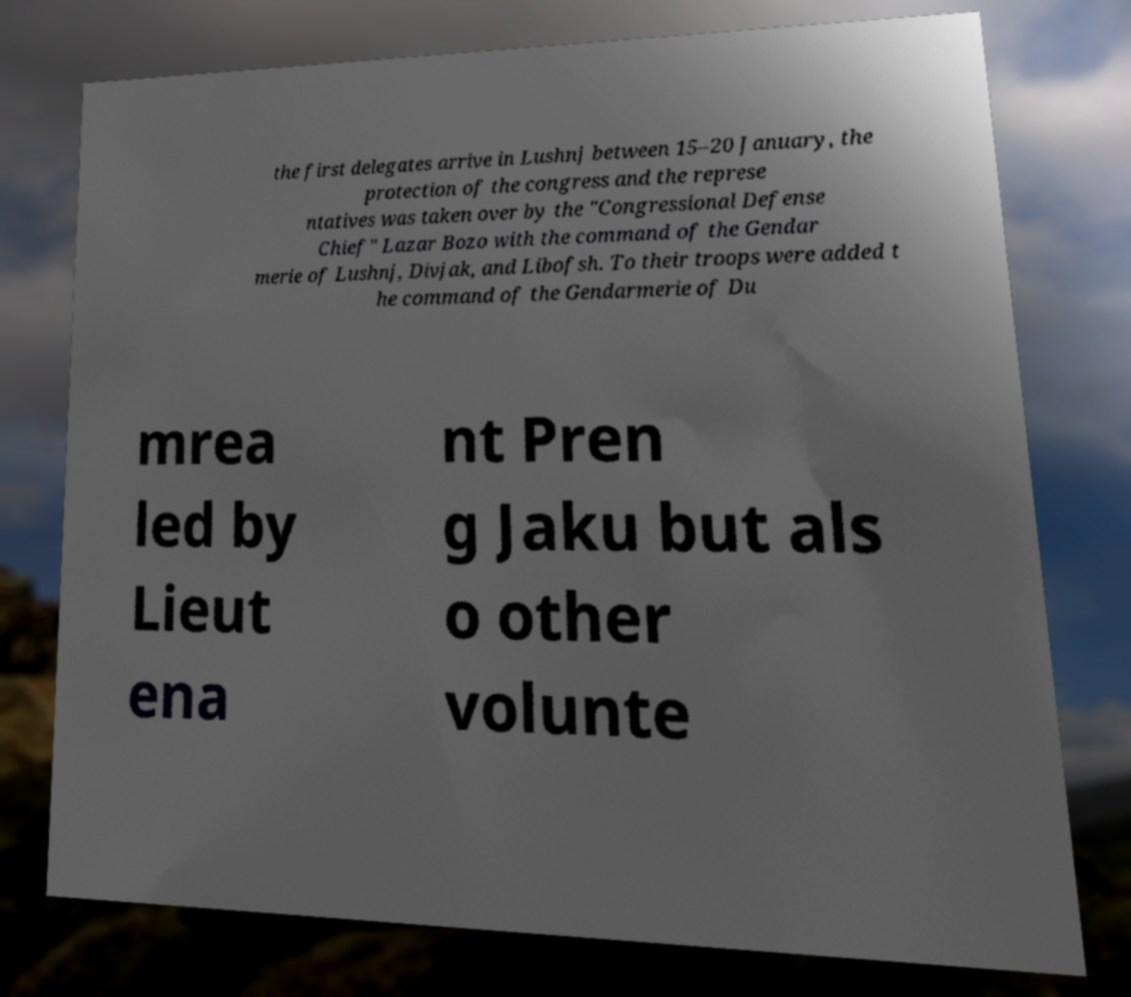Please identify and transcribe the text found in this image. the first delegates arrive in Lushnj between 15–20 January, the protection of the congress and the represe ntatives was taken over by the "Congressional Defense Chief" Lazar Bozo with the command of the Gendar merie of Lushnj, Divjak, and Libofsh. To their troops were added t he command of the Gendarmerie of Du mrea led by Lieut ena nt Pren g Jaku but als o other volunte 